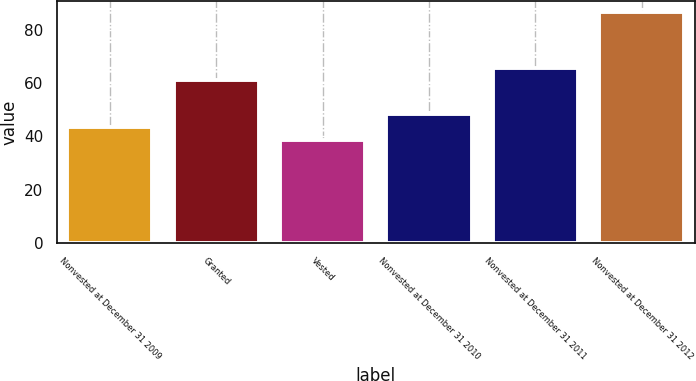Convert chart to OTSL. <chart><loc_0><loc_0><loc_500><loc_500><bar_chart><fcel>Nonvested at December 31 2009<fcel>Granted<fcel>Vested<fcel>Nonvested at December 31 2010<fcel>Nonvested at December 31 2011<fcel>Nonvested at December 31 2012<nl><fcel>43.41<fcel>60.92<fcel>38.62<fcel>48.2<fcel>65.71<fcel>86.49<nl></chart> 